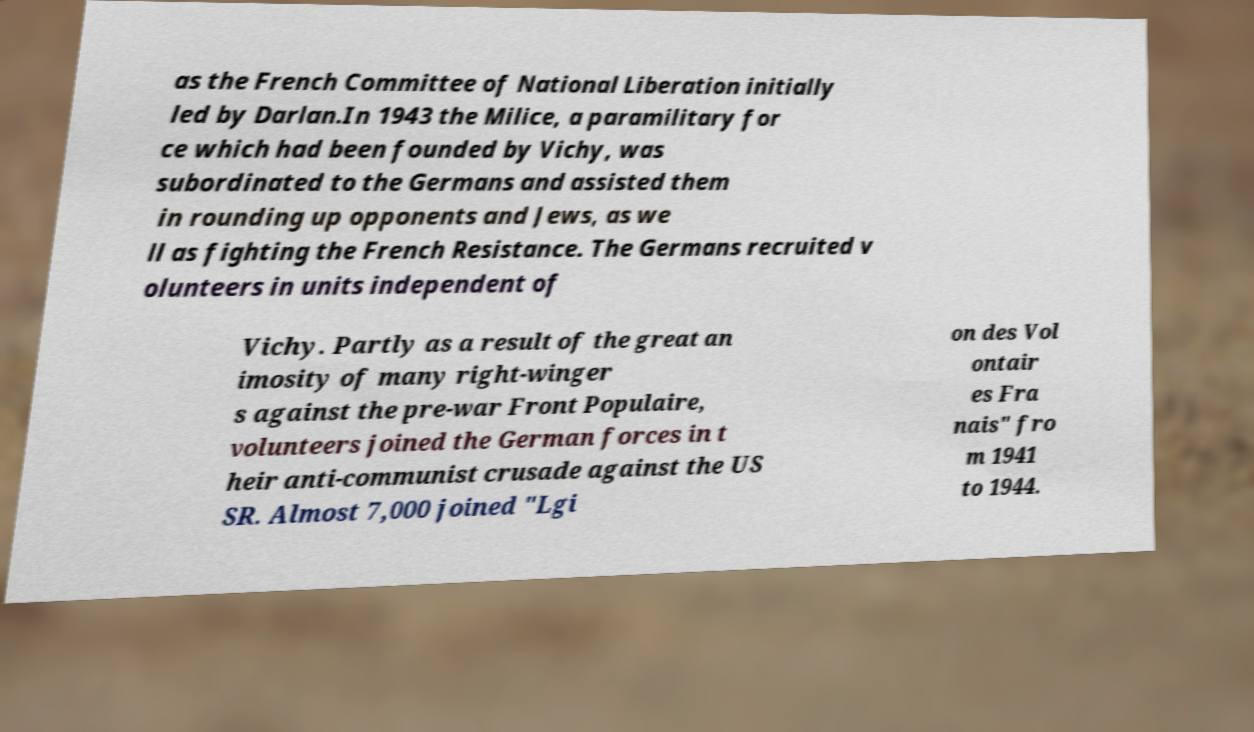Please identify and transcribe the text found in this image. as the French Committee of National Liberation initially led by Darlan.In 1943 the Milice, a paramilitary for ce which had been founded by Vichy, was subordinated to the Germans and assisted them in rounding up opponents and Jews, as we ll as fighting the French Resistance. The Germans recruited v olunteers in units independent of Vichy. Partly as a result of the great an imosity of many right-winger s against the pre-war Front Populaire, volunteers joined the German forces in t heir anti-communist crusade against the US SR. Almost 7,000 joined "Lgi on des Vol ontair es Fra nais" fro m 1941 to 1944. 